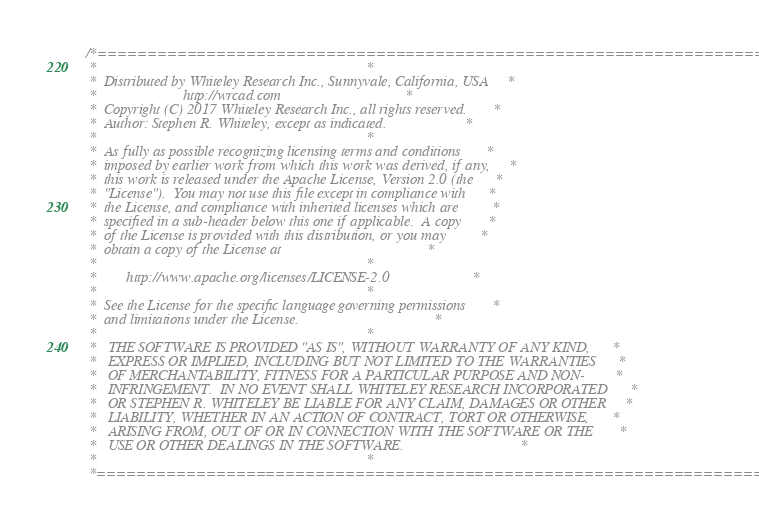Convert code to text. <code><loc_0><loc_0><loc_500><loc_500><_C_>
/*========================================================================*
 *                                                                        *
 *  Distributed by Whiteley Research Inc., Sunnyvale, California, USA     *
 *                       http://wrcad.com                                 *
 *  Copyright (C) 2017 Whiteley Research Inc., all rights reserved.       *
 *  Author: Stephen R. Whiteley, except as indicated.                     *
 *                                                                        *
 *  As fully as possible recognizing licensing terms and conditions       *
 *  imposed by earlier work from which this work was derived, if any,     *
 *  this work is released under the Apache License, Version 2.0 (the      *
 *  "License").  You may not use this file except in compliance with      *
 *  the License, and compliance with inherited licenses which are         *
 *  specified in a sub-header below this one if applicable.  A copy       *
 *  of the License is provided with this distribution, or you may         *
 *  obtain a copy of the License at                                       *
 *                                                                        *
 *        http://www.apache.org/licenses/LICENSE-2.0                      *
 *                                                                        *
 *  See the License for the specific language governing permissions       *
 *  and limitations under the License.                                    *
 *                                                                        *
 *   THE SOFTWARE IS PROVIDED "AS IS", WITHOUT WARRANTY OF ANY KIND,      *
 *   EXPRESS OR IMPLIED, INCLUDING BUT NOT LIMITED TO THE WARRANTIES      *
 *   OF MERCHANTABILITY, FITNESS FOR A PARTICULAR PURPOSE AND NON-        *
 *   INFRINGEMENT.  IN NO EVENT SHALL WHITELEY RESEARCH INCORPORATED      *
 *   OR STEPHEN R. WHITELEY BE LIABLE FOR ANY CLAIM, DAMAGES OR OTHER     *
 *   LIABILITY, WHETHER IN AN ACTION OF CONTRACT, TORT OR OTHERWISE,      *
 *   ARISING FROM, OUT OF OR IN CONNECTION WITH THE SOFTWARE OR THE       *
 *   USE OR OTHER DEALINGS IN THE SOFTWARE.                               *
 *                                                                        *
 *========================================================================*</code> 